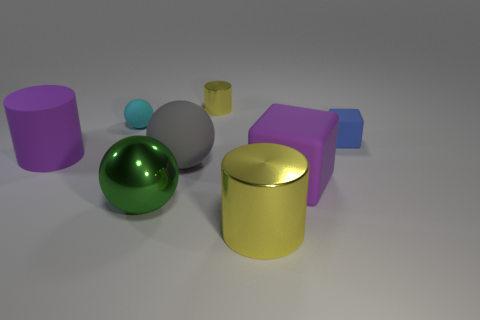Add 1 green metallic objects. How many objects exist? 9 Subtract all cubes. How many objects are left? 6 Add 3 big matte balls. How many big matte balls are left? 4 Add 2 big purple cylinders. How many big purple cylinders exist? 3 Subtract 0 blue spheres. How many objects are left? 8 Subtract all cyan cylinders. Subtract all tiny cyan matte balls. How many objects are left? 7 